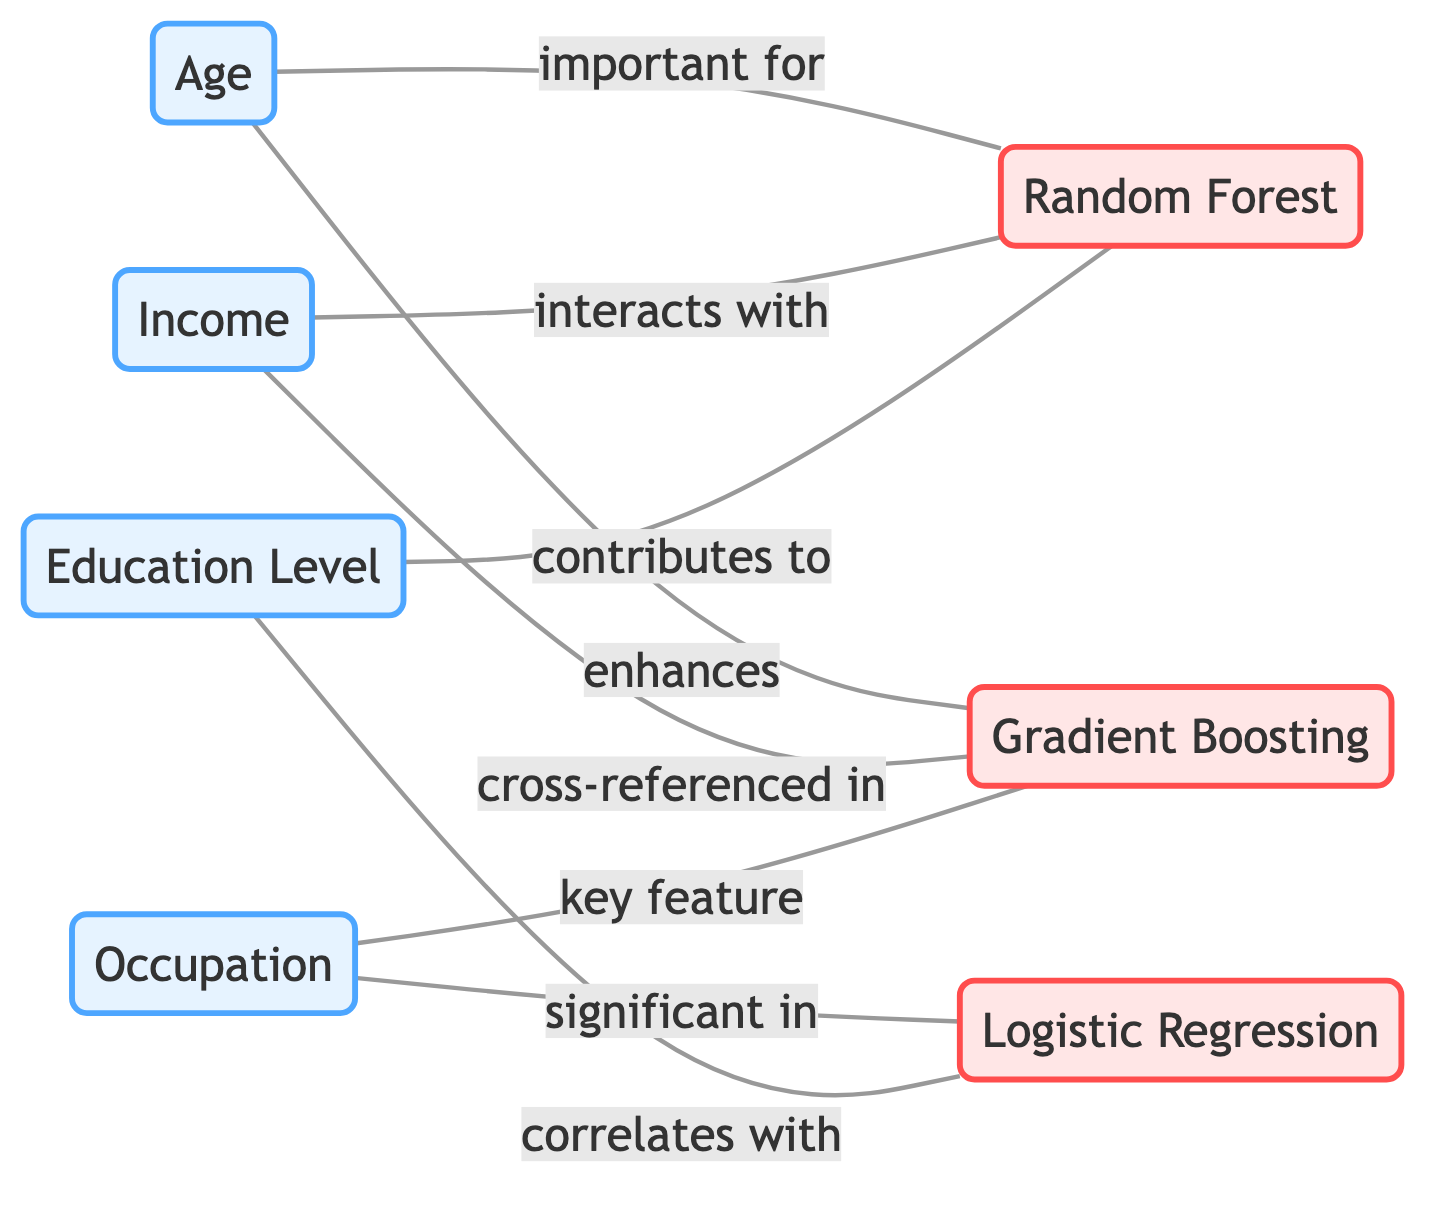What is the label of the node that represents the model related to "Age"? The node that represents the model related to "Age" is "Random Forest". The relationship is indicated by the edge connecting the node "Age" (feature_1) to "Random Forest" (model_1) with the label "important for".
Answer: Random Forest How many features are displayed in the diagram? The diagram includes four feature nodes: "Age", "Income", "Occupation", and "Education Level". Counting them gives us a total of four feature nodes.
Answer: 4 Which model does "Education Level" correlate with? The edge from "Education Level" (feature_4) leads to "Logistic Regression" (model_2) with the label "correlates with", indicating this relationship.
Answer: Logistic Regression What is the relationship between "Income" and "Gradient Boosting"? There is no direct edge indicating a specific relationship between "Income" (feature_2) and "Gradient Boosting" (model_3), indicating that they are not directly connected in terms of feature interaction in this diagram.
Answer: None Which feature is significant in "Logistic Regression"? The diagram shows that "Occupation" (feature_3) is connected to "Logistic Regression" (model_2) with the label "significant in", indicating the importance of this feature.
Answer: Occupation How many edges connect features to models in total? By counting the edges in the diagram, we find a total of eight edges connecting the four features to the three models.
Answer: 8 Which feature contributes to the "Random Forest" model? The edge connects "Education Level" (feature_4) to "Random Forest" (model_1) with the label "contributes to", indicating its contribution to this model.
Answer: Education Level What is the overall purpose of the diagram? The purpose of the diagram is to analyze the relationships and interactions of different features across various machine learning models, showcasing how features are important, interact, or correlate with specific models.
Answer: Analyze feature interactions 